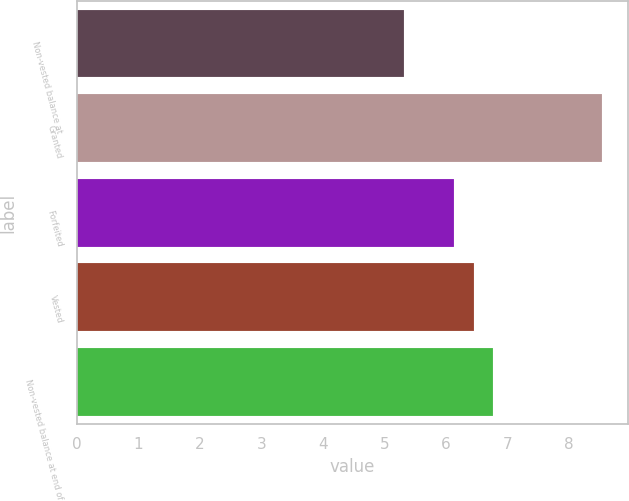Convert chart to OTSL. <chart><loc_0><loc_0><loc_500><loc_500><bar_chart><fcel>Non-vested balance at<fcel>Granted<fcel>Forfeited<fcel>Vested<fcel>Non-vested balance at end of<nl><fcel>5.32<fcel>8.54<fcel>6.13<fcel>6.45<fcel>6.77<nl></chart> 